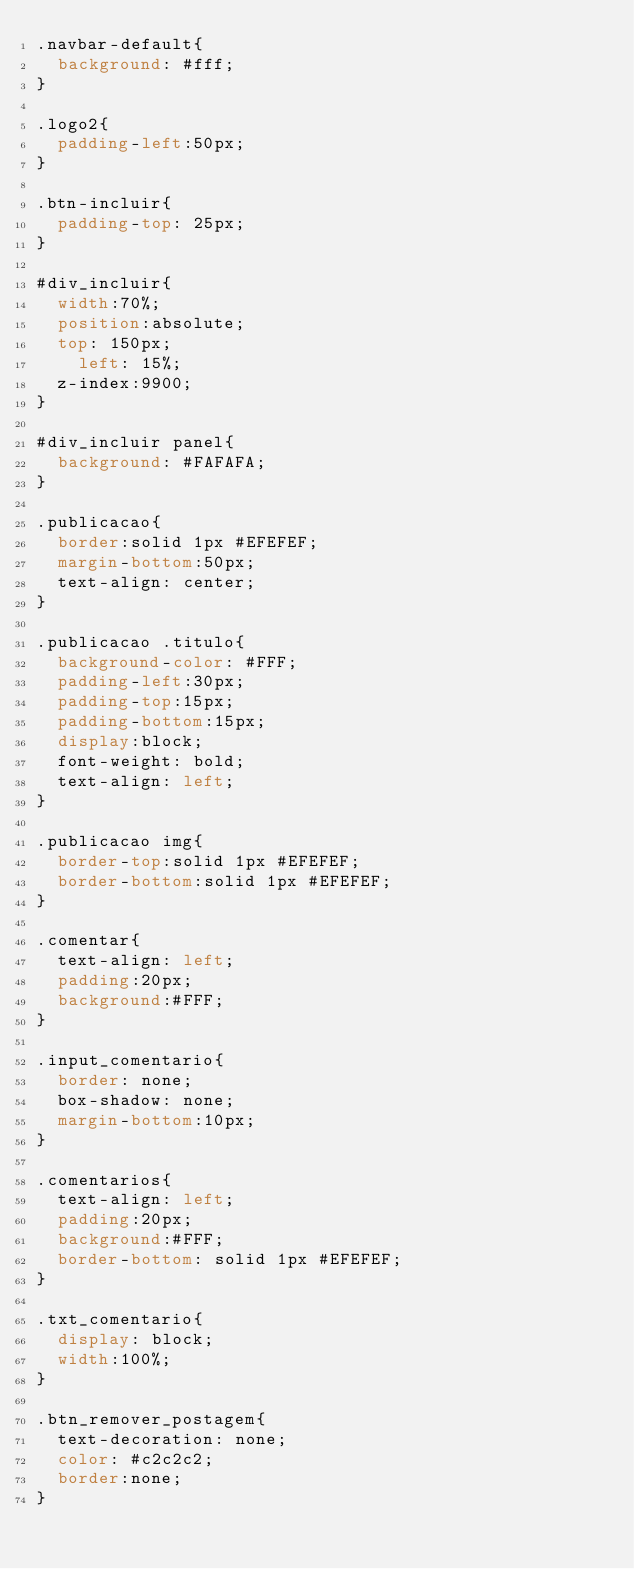<code> <loc_0><loc_0><loc_500><loc_500><_CSS_>.navbar-default{
	background: #fff;
}

.logo2{
	padding-left:50px;
}

.btn-incluir{
	padding-top: 25px;
}

#div_incluir{
	width:70%;
	position:absolute;
	top: 150px;
    left: 15%;
	z-index:9900;
}

#div_incluir panel{
	background: #FAFAFA;
}

.publicacao{
	border:solid 1px #EFEFEF;
	margin-bottom:50px;
	text-align: center;
}

.publicacao .titulo{
	background-color: #FFF;
	padding-left:30px;
	padding-top:15px;
	padding-bottom:15px;
	display:block;
	font-weight: bold;
	text-align: left;
}

.publicacao img{
	border-top:solid 1px #EFEFEF;
	border-bottom:solid 1px #EFEFEF;
}

.comentar{
	text-align: left;
	padding:20px;
	background:#FFF;
}

.input_comentario{
	border: none;
	box-shadow: none;
	margin-bottom:10px;
}

.comentarios{
	text-align: left;
	padding:20px;
	background:#FFF;
	border-bottom: solid 1px #EFEFEF;
}

.txt_comentario{
	display: block;
	width:100%;
}

.btn_remover_postagem{
	text-decoration: none;
	color: #c2c2c2;
	border:none;
}</code> 